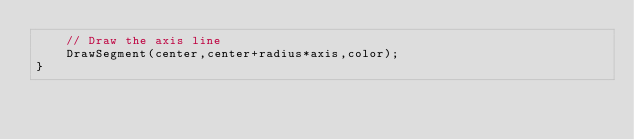<code> <loc_0><loc_0><loc_500><loc_500><_ObjectiveC_>	// Draw the axis line
	DrawSegment(center,center+radius*axis,color);
}
</code> 